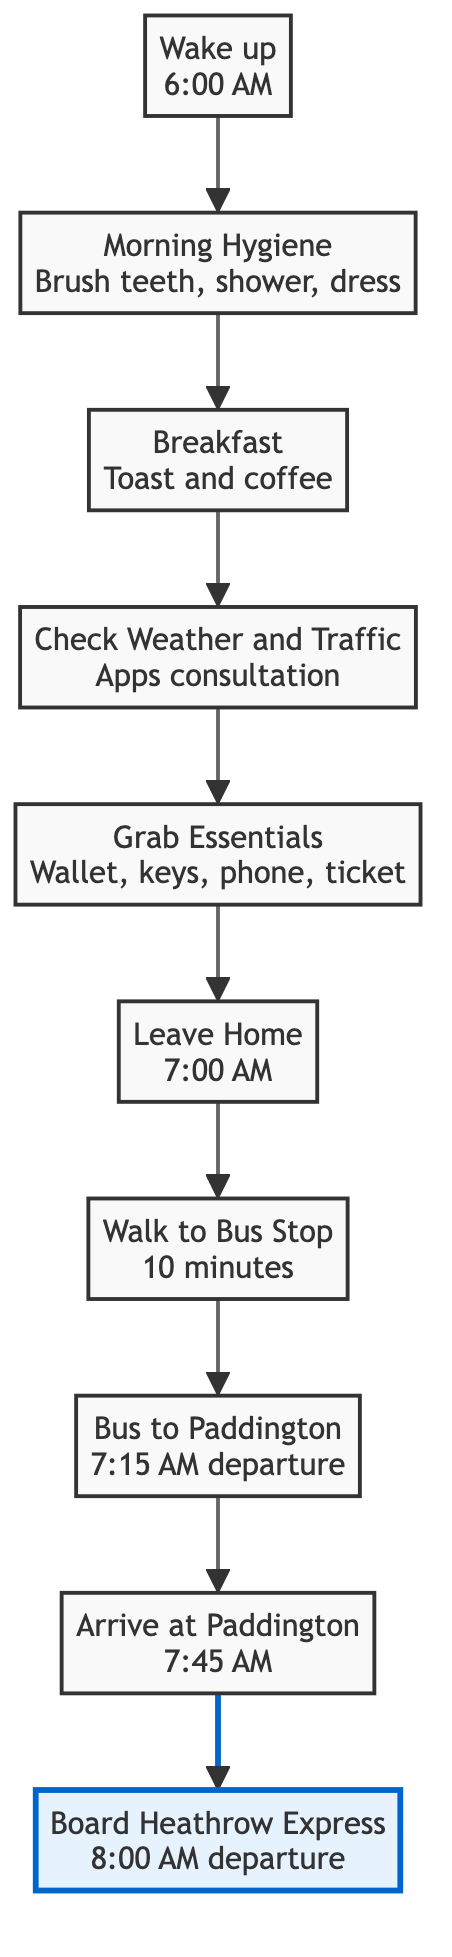What is the first step in the morning routine? The first step in the morning routine is "Wake up", which is indicated as the starting point in the diagram.
Answer: Wake up What time is the alarm set for? The alarm is set for 6:00 AM, which is detailed in the first step of the diagram.
Answer: 6:00 AM How long does it take to walk to the local bus stop? The diagram states that it takes a "10-minute walk to the bus stop", indicating the duration of this step.
Answer: 10 minutes What is the last action before boarding the Heathrow Express? The last action before boarding the Heathrow Express is to "Arrive at Paddington", which leads directly to the boarding action in the flow.
Answer: Arrive at Paddington How many total steps are there in the morning routine? There are 10 steps delineated in the diagram, as indicated by each unique action listed from start to finish.
Answer: 10 steps What step follows "Grab Essentials"? The step that follows "Grab Essentials" is "Leave Home", which can be confirmed by tracing the arrows in the diagram.
Answer: Leave Home What is the scheduled departure time of the Heathrow Express? The diagram specifies that the scheduled departure time for the Heathrow Express is "8:00 AM".
Answer: 8:00 AM How does the process flow from breakfast to checking the weather? From "Breakfast", the flow moves to "Check Weather and Traffic", indicating that after having breakfast, the next action is to check the weather and traffic conditions.
Answer: Check Weather and Traffic What key items should be grabbed before leaving home? The key items listed are "Wallet, keys, phone, and Heathrow Express ticket", which are essential to be taken before departure.
Answer: Wallet, keys, phone, ticket 